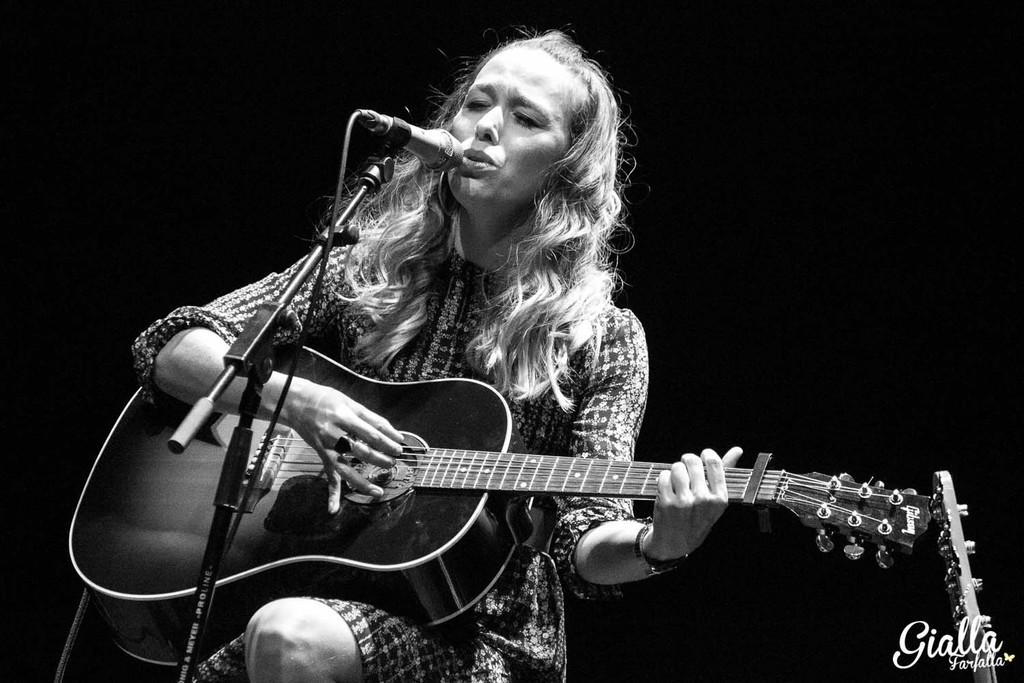Who is the main subject in the image? There is a woman in the image. What is the woman doing in the image? The woman is sitting, playing a guitar, and singing. What object is present in the image that is commonly used for amplifying sound? There is a microphone in the image. Where is the boy holding the balloon in the image? There is no boy or balloon present in the image. What type of hook is the woman using to play the guitar in the image? The woman is not using a hook to play the guitar; she is using her hands. 